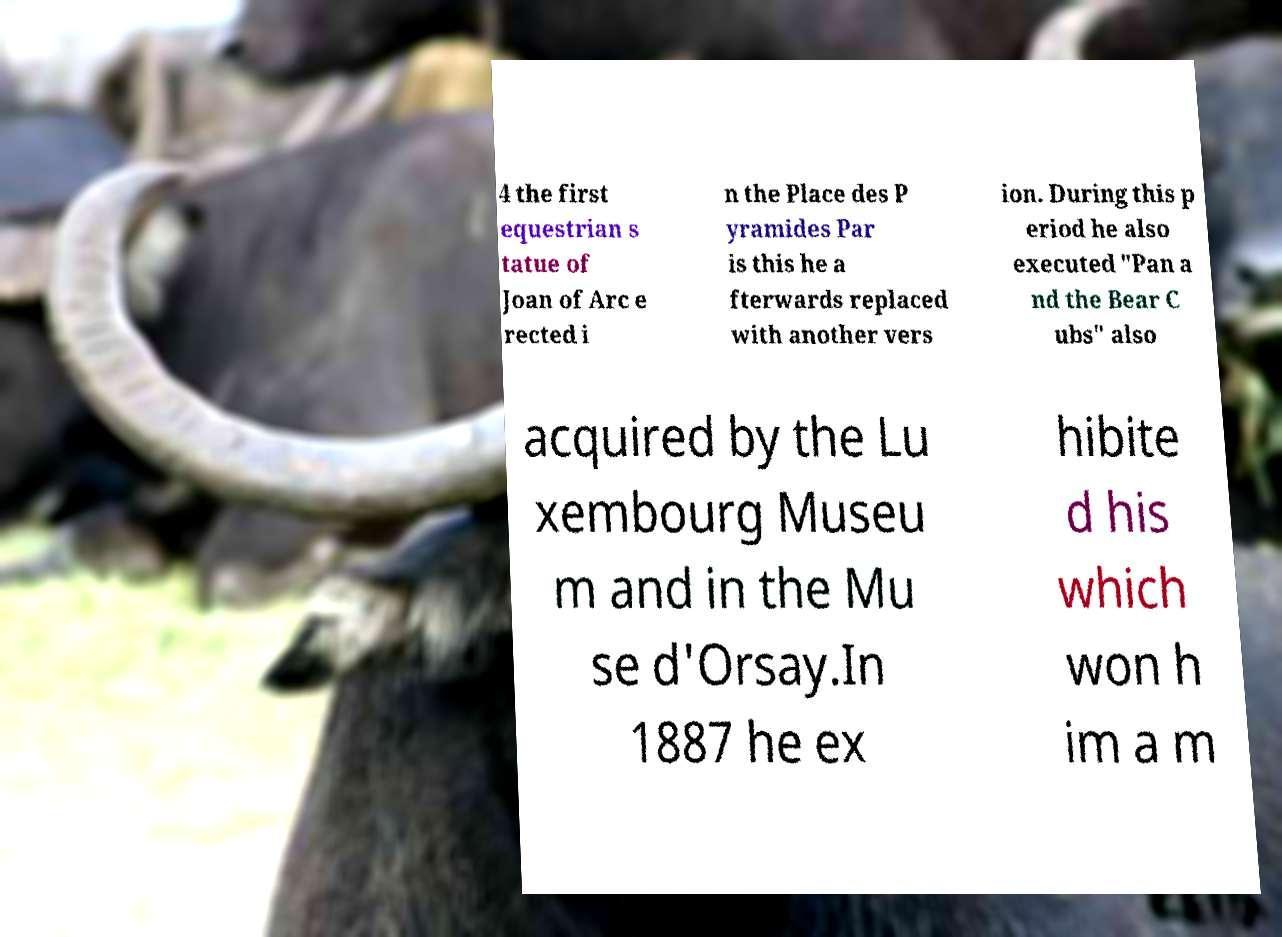There's text embedded in this image that I need extracted. Can you transcribe it verbatim? 4 the first equestrian s tatue of Joan of Arc e rected i n the Place des P yramides Par is this he a fterwards replaced with another vers ion. During this p eriod he also executed "Pan a nd the Bear C ubs" also acquired by the Lu xembourg Museu m and in the Mu se d'Orsay.In 1887 he ex hibite d his which won h im a m 